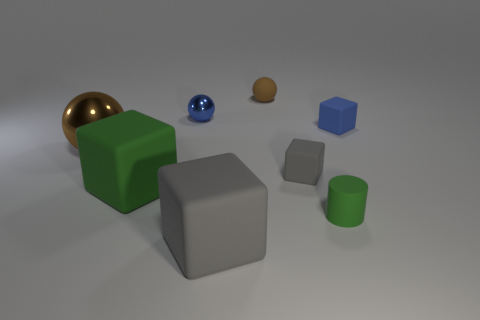Does the small thing that is in front of the small gray rubber object have the same material as the sphere in front of the blue cube?
Your answer should be compact. No. What number of cyan rubber things are there?
Give a very brief answer. 0. There is a small matte thing to the right of the tiny matte cylinder; what shape is it?
Provide a succinct answer. Cube. How many other objects are there of the same size as the blue matte cube?
Your answer should be compact. 4. Is the shape of the green thing that is on the left side of the big gray matte block the same as the large gray matte thing in front of the tiny rubber ball?
Keep it short and to the point. Yes. How many rubber cylinders are on the left side of the small green cylinder?
Provide a succinct answer. 0. There is a tiny block that is to the right of the small gray cube; what is its color?
Your answer should be very brief. Blue. There is another large rubber object that is the same shape as the big green object; what is its color?
Keep it short and to the point. Gray. Are there more small yellow rubber cylinders than shiny spheres?
Your answer should be very brief. No. Is the cylinder made of the same material as the blue sphere?
Give a very brief answer. No. 